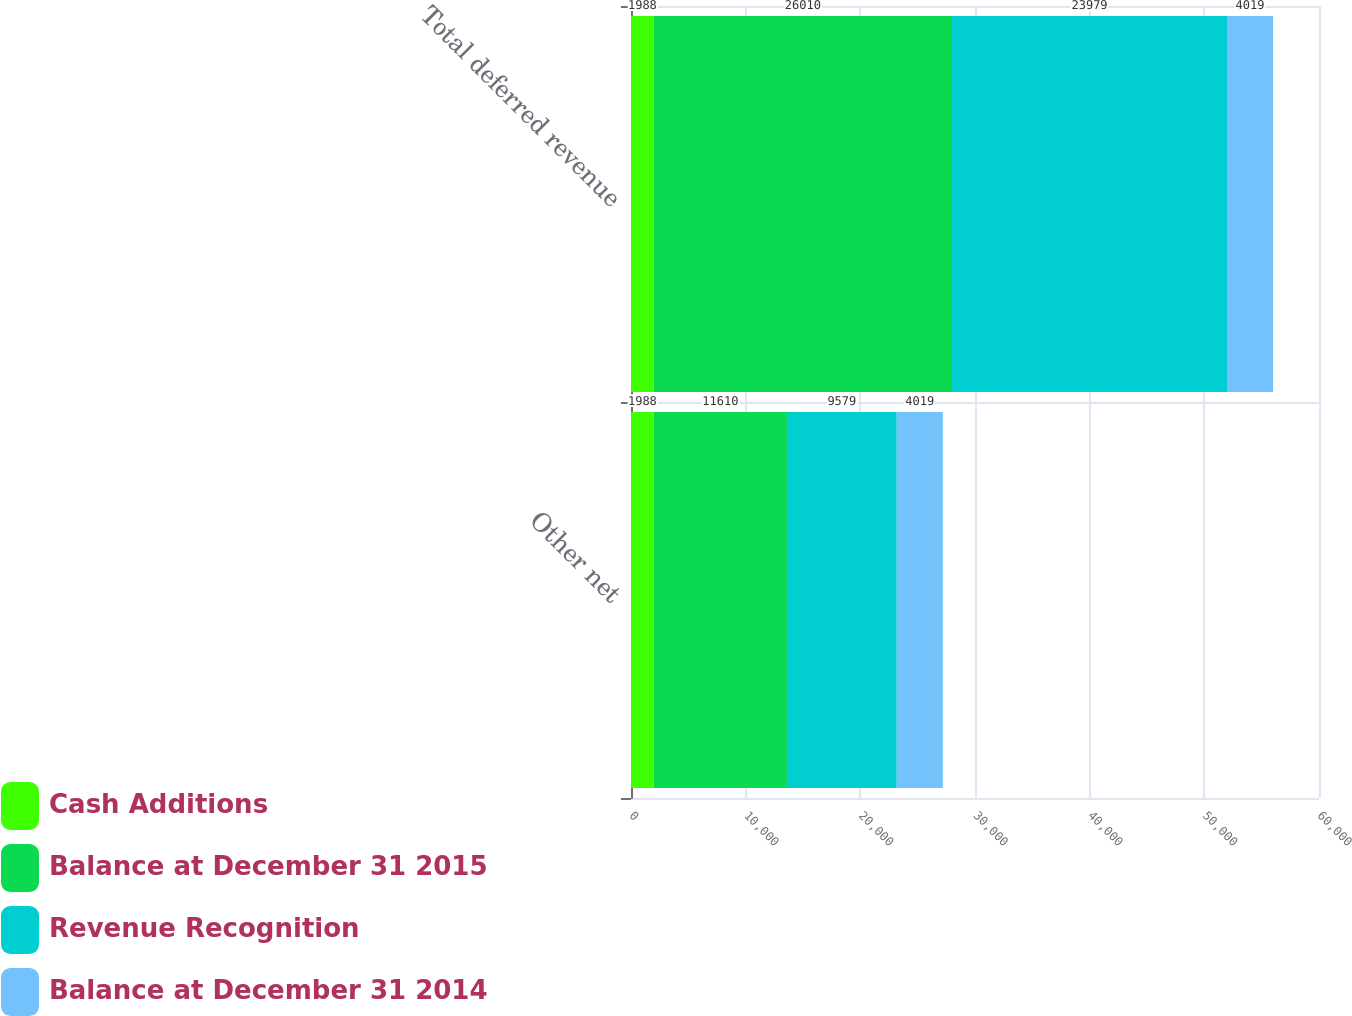<chart> <loc_0><loc_0><loc_500><loc_500><stacked_bar_chart><ecel><fcel>Other net<fcel>Total deferred revenue<nl><fcel>Cash Additions<fcel>1988<fcel>1988<nl><fcel>Balance at December 31 2015<fcel>11610<fcel>26010<nl><fcel>Revenue Recognition<fcel>9579<fcel>23979<nl><fcel>Balance at December 31 2014<fcel>4019<fcel>4019<nl></chart> 